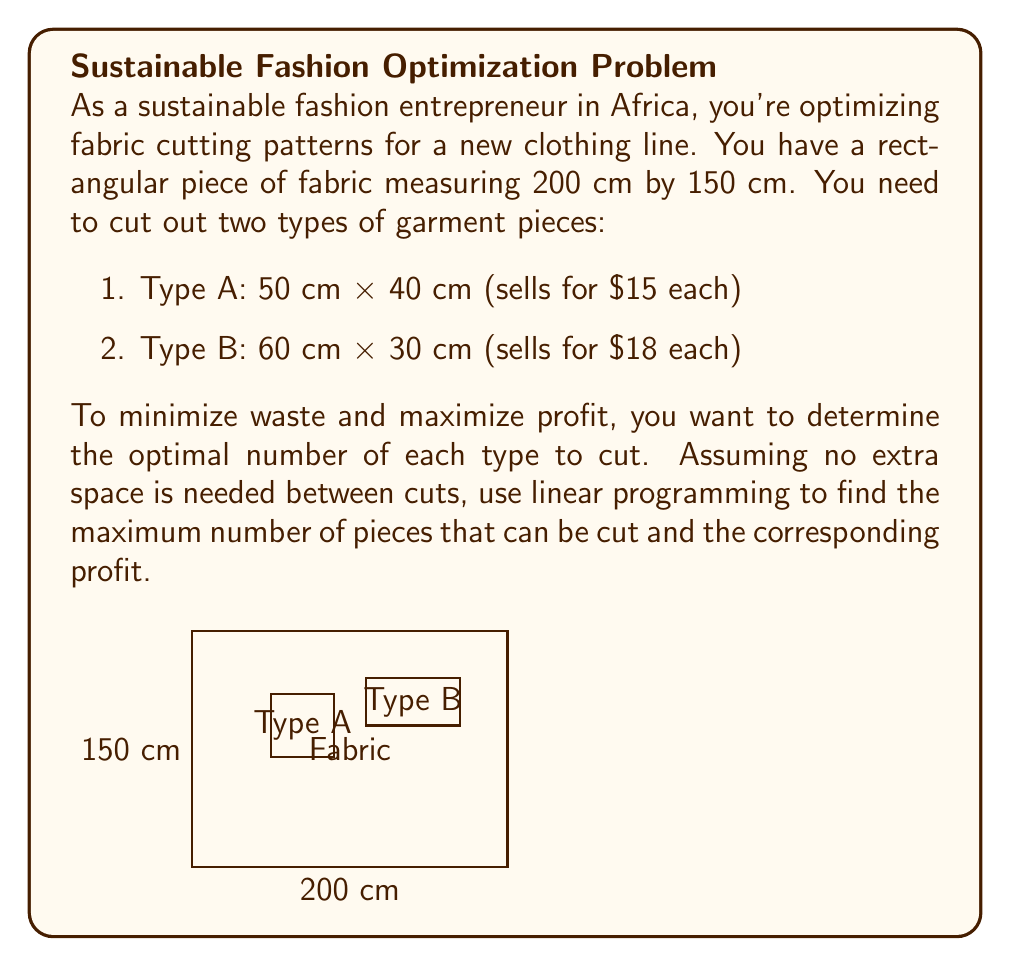Show me your answer to this math problem. Let's approach this step-by-step using linear programming:

1) Define variables:
   Let $x$ = number of Type A pieces
   Let $y$ = number of Type B pieces

2) Objective function (to maximize profit):
   $$ \text{Maximize } Z = 15x + 18y $$

3) Constraints:
   a) Width constraint: Each row can fit either 4 Type A or 3 Type B pieces
      $$ 50x + 60y \leq 200 \cdot 3 = 600 $$
   b) Height constraint: Each column can fit either 3 Type A or 5 Type B pieces
      $$ 40x + 30y \leq 150 \cdot 5 = 750 $$
   c) Non-negativity: $x \geq 0, y \geq 0$

4) Solve graphically or using the simplex method. The feasible region is bounded by:
   $$ 50x + 60y = 600 $$
   $$ 40x + 30y = 750 $$

5) Calculate intersection points:
   (0, 10), (12, 0), and (9, 5)

6) Evaluate the objective function at these points:
   (0, 10): $Z = 15(0) + 18(10) = 180$
   (12, 0): $Z = 15(12) + 18(0) = 180$
   (9, 5): $Z = 15(9) + 18(5) = 225$

7) The optimal solution is at (9, 5), meaning 9 Type A pieces and 5 Type B pieces.

8) Maximum profit: $225

Therefore, to minimize waste and maximize profit, cut 9 Type A pieces and 5 Type B pieces.
Answer: 9 Type A, 5 Type B; $225 profit 